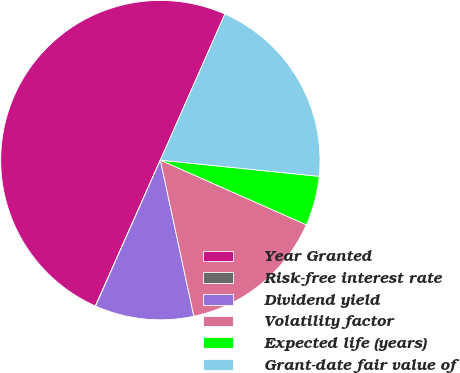<chart> <loc_0><loc_0><loc_500><loc_500><pie_chart><fcel>Year Granted<fcel>Risk-free interest rate<fcel>Dividend yield<fcel>Volatility factor<fcel>Expected life (years)<fcel>Grant-date fair value of<nl><fcel>49.96%<fcel>0.02%<fcel>10.01%<fcel>15.0%<fcel>5.02%<fcel>20.0%<nl></chart> 